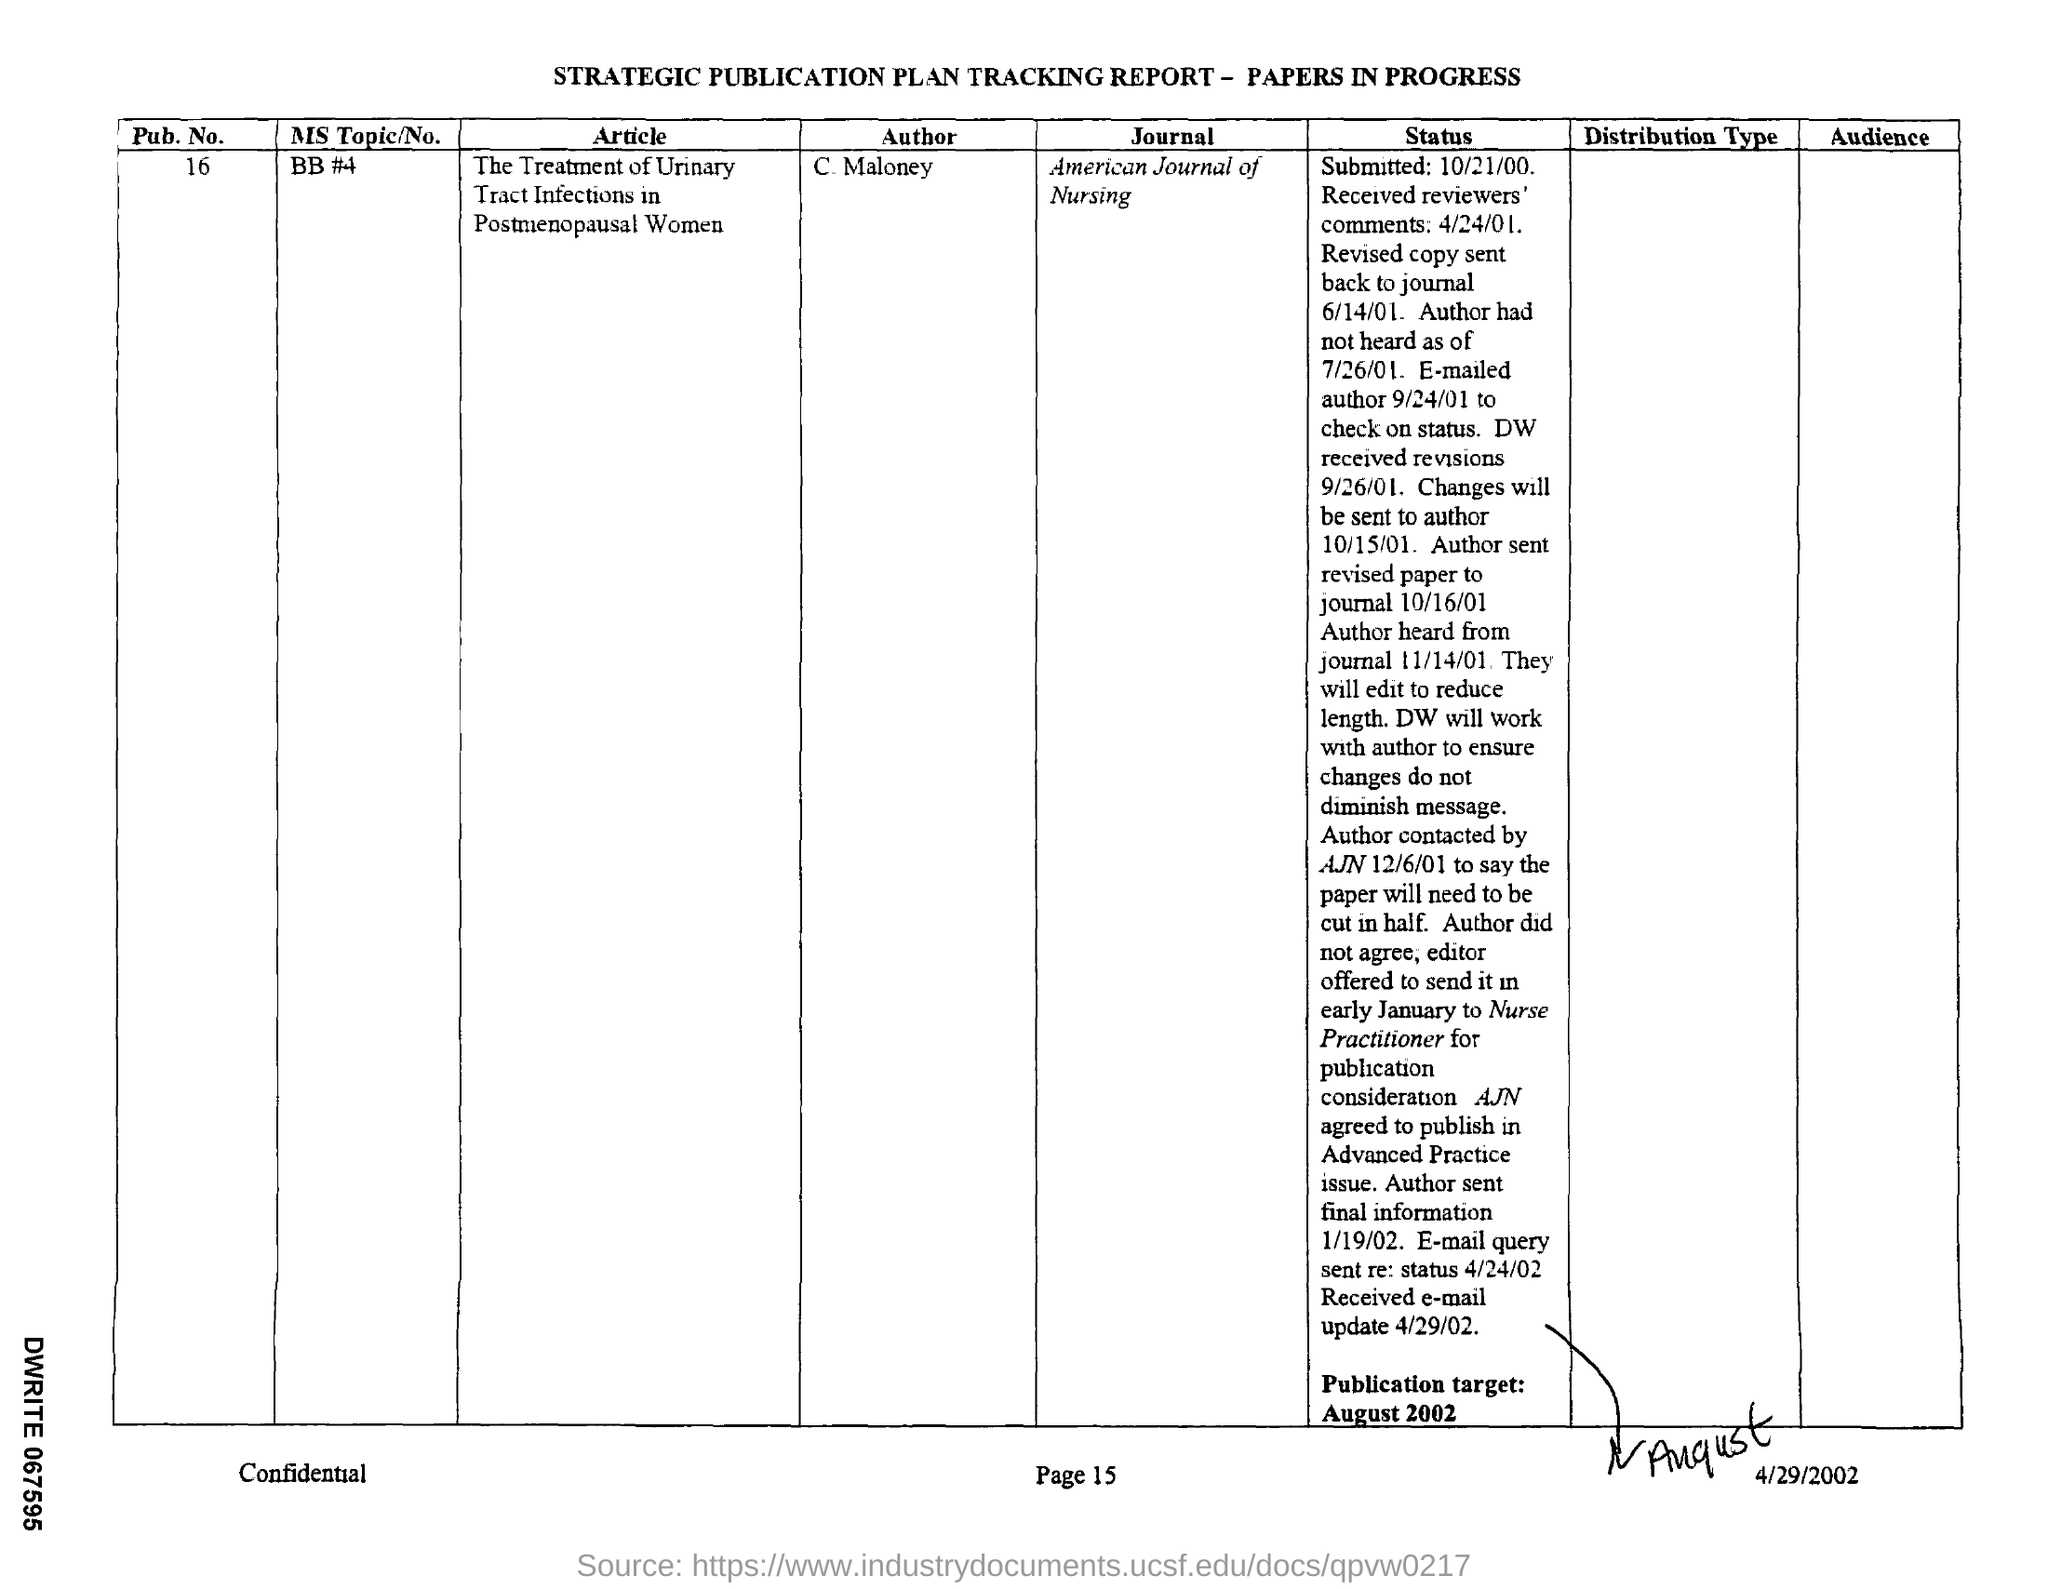Point out several critical features in this image. The pub.no. mentioned in the report is 16.. The publication target given in the report is August 2002. The tracking report mentions a journal called the "American Journal of Nursing. The author mentioned in the given tracking report is C. Maloney. The article named in the given tracking report is titled 'The Treatment of Urinary Tract Infections in Postmenopausal Women'. 